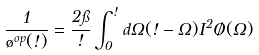Convert formula to latex. <formula><loc_0><loc_0><loc_500><loc_500>\frac { 1 } { \tau ^ { o p } ( \omega ) } = \frac { 2 \pi } { \omega } \int ^ { \omega } _ { 0 } d \Omega ( \omega - \Omega ) I ^ { 2 } \chi ( \Omega )</formula> 